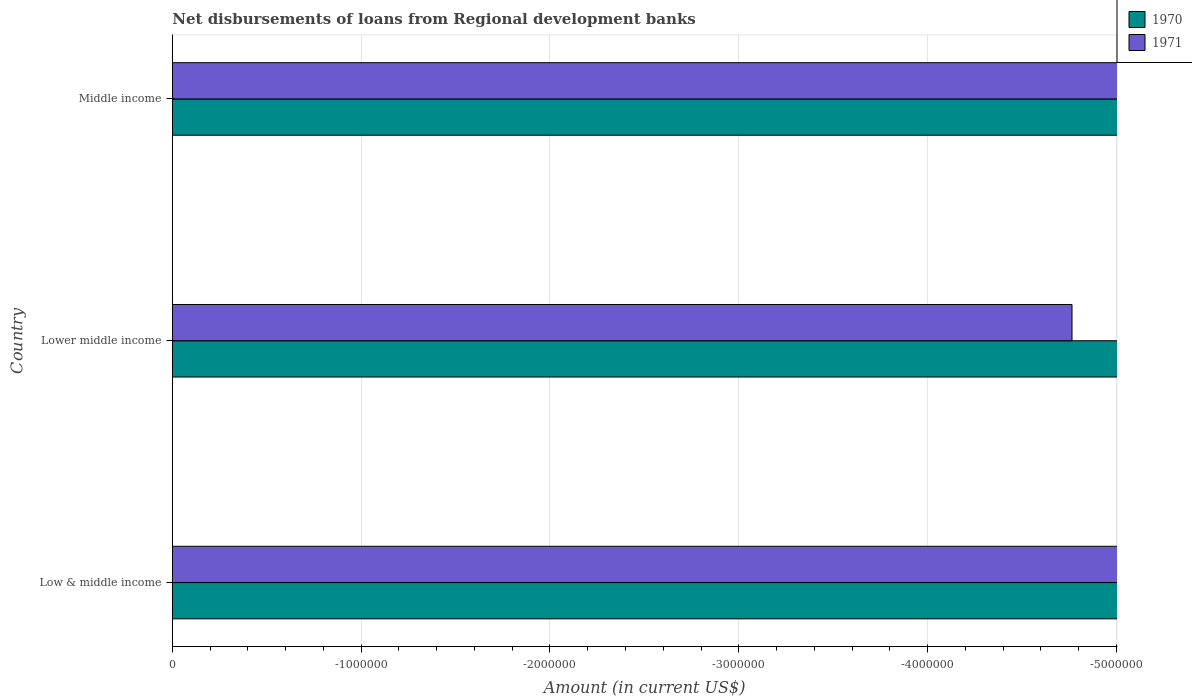Are the number of bars per tick equal to the number of legend labels?
Your answer should be compact. No. Are the number of bars on each tick of the Y-axis equal?
Give a very brief answer. Yes. How many bars are there on the 3rd tick from the bottom?
Make the answer very short. 0. In how many cases, is the number of bars for a given country not equal to the number of legend labels?
Give a very brief answer. 3. Across all countries, what is the minimum amount of disbursements of loans from regional development banks in 1970?
Provide a short and direct response. 0. What is the total amount of disbursements of loans from regional development banks in 1971 in the graph?
Make the answer very short. 0. What is the difference between the amount of disbursements of loans from regional development banks in 1970 in Low & middle income and the amount of disbursements of loans from regional development banks in 1971 in Middle income?
Your answer should be compact. 0. What is the average amount of disbursements of loans from regional development banks in 1970 per country?
Offer a very short reply. 0. In how many countries, is the amount of disbursements of loans from regional development banks in 1970 greater than -3000000 US$?
Ensure brevity in your answer.  0. How many countries are there in the graph?
Offer a very short reply. 3. What is the difference between two consecutive major ticks on the X-axis?
Offer a terse response. 1.00e+06. Are the values on the major ticks of X-axis written in scientific E-notation?
Offer a terse response. No. Does the graph contain grids?
Provide a succinct answer. Yes. How many legend labels are there?
Your answer should be very brief. 2. What is the title of the graph?
Offer a very short reply. Net disbursements of loans from Regional development banks. Does "2004" appear as one of the legend labels in the graph?
Offer a terse response. No. What is the label or title of the Y-axis?
Provide a short and direct response. Country. What is the Amount (in current US$) in 1971 in Low & middle income?
Ensure brevity in your answer.  0. What is the Amount (in current US$) of 1971 in Middle income?
Offer a very short reply. 0. What is the total Amount (in current US$) in 1970 in the graph?
Keep it short and to the point. 0. What is the average Amount (in current US$) in 1970 per country?
Offer a terse response. 0. What is the average Amount (in current US$) of 1971 per country?
Offer a very short reply. 0. 